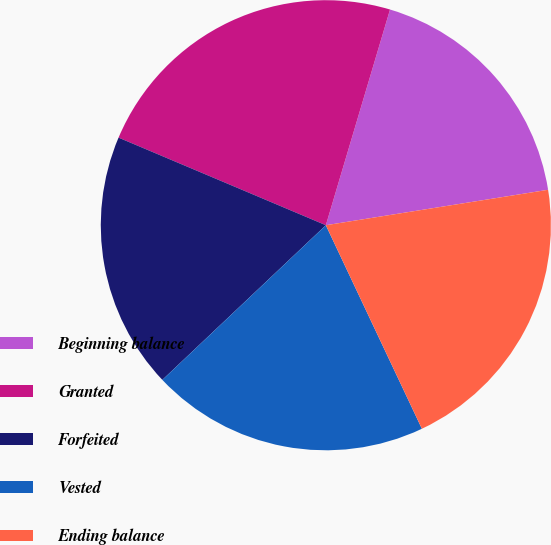Convert chart to OTSL. <chart><loc_0><loc_0><loc_500><loc_500><pie_chart><fcel>Beginning balance<fcel>Granted<fcel>Forfeited<fcel>Vested<fcel>Ending balance<nl><fcel>17.88%<fcel>23.24%<fcel>18.42%<fcel>19.96%<fcel>20.5%<nl></chart> 